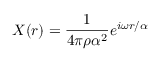<formula> <loc_0><loc_0><loc_500><loc_500>X ( r ) = \frac { 1 } { 4 \pi \rho \alpha ^ { 2 } } e ^ { i \omega r / \alpha }</formula> 